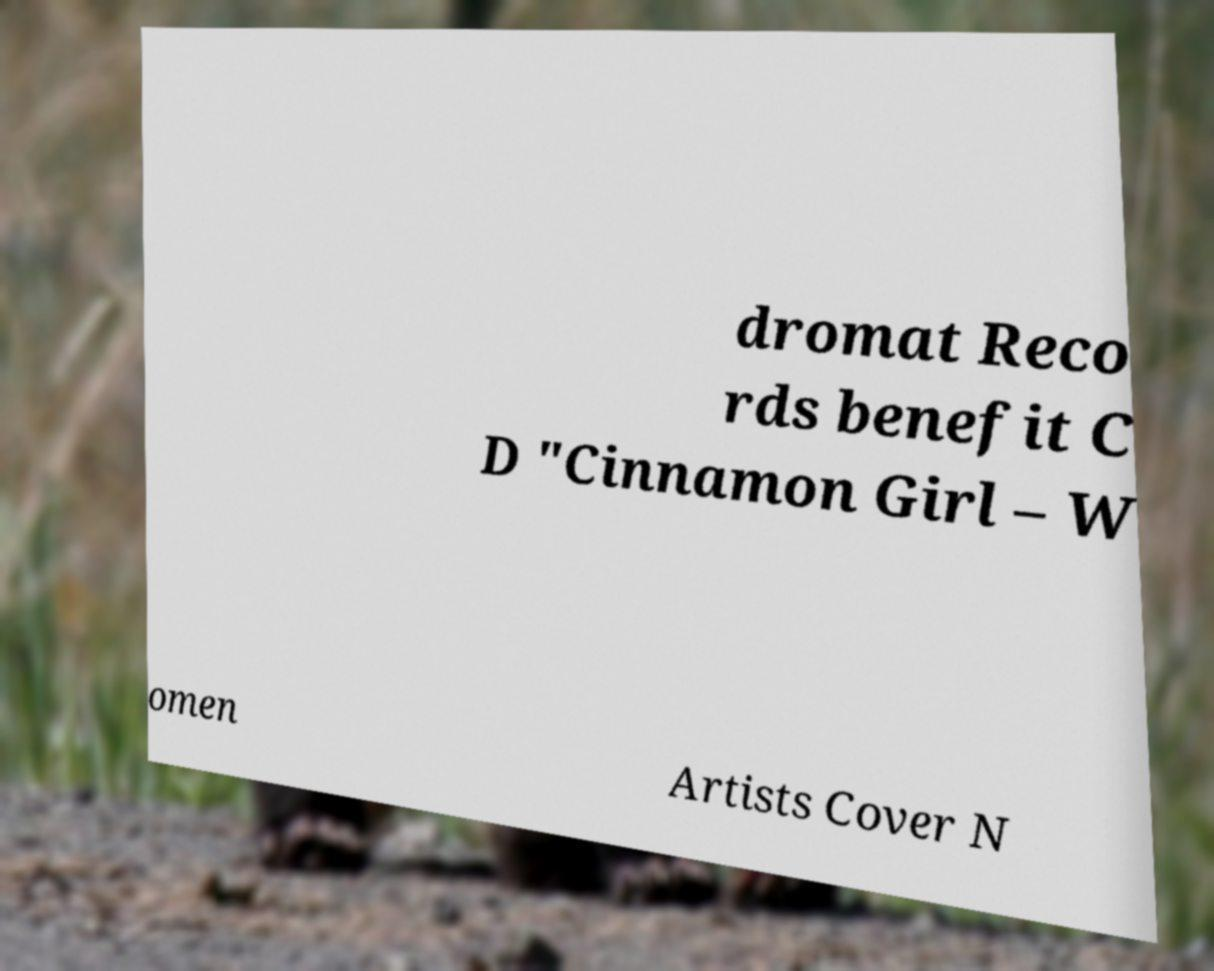There's text embedded in this image that I need extracted. Can you transcribe it verbatim? dromat Reco rds benefit C D "Cinnamon Girl – W omen Artists Cover N 